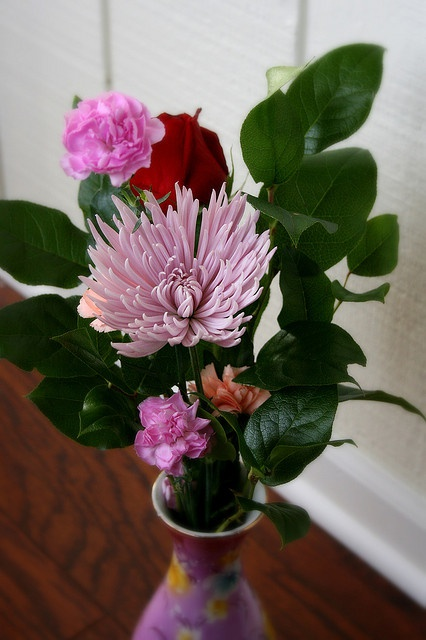Describe the objects in this image and their specific colors. I can see a vase in lightgray, maroon, black, and purple tones in this image. 